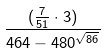<formula> <loc_0><loc_0><loc_500><loc_500>\frac { ( \frac { 7 } { 5 1 } \cdot 3 ) } { 4 6 4 - 4 8 0 ^ { \sqrt { 8 6 } } }</formula> 